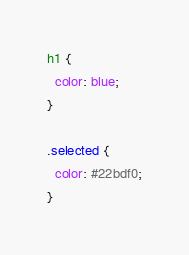<code> <loc_0><loc_0><loc_500><loc_500><_CSS_>h1 {
  color: blue;
}

.selected {
  color: #22bdf0;
}
</code> 